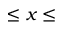Convert formula to latex. <formula><loc_0><loc_0><loc_500><loc_500>\leq x \leq</formula> 